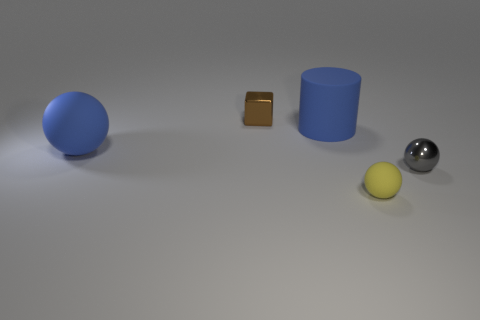Subtract all matte spheres. How many spheres are left? 1 Add 1 small brown shiny things. How many objects exist? 6 Subtract all cyan spheres. Subtract all red cylinders. How many spheres are left? 3 Subtract all cubes. How many objects are left? 4 Add 2 tiny metal things. How many tiny metal things exist? 4 Subtract 0 cyan spheres. How many objects are left? 5 Subtract all small blue cylinders. Subtract all small brown metal things. How many objects are left? 4 Add 2 shiny balls. How many shiny balls are left? 3 